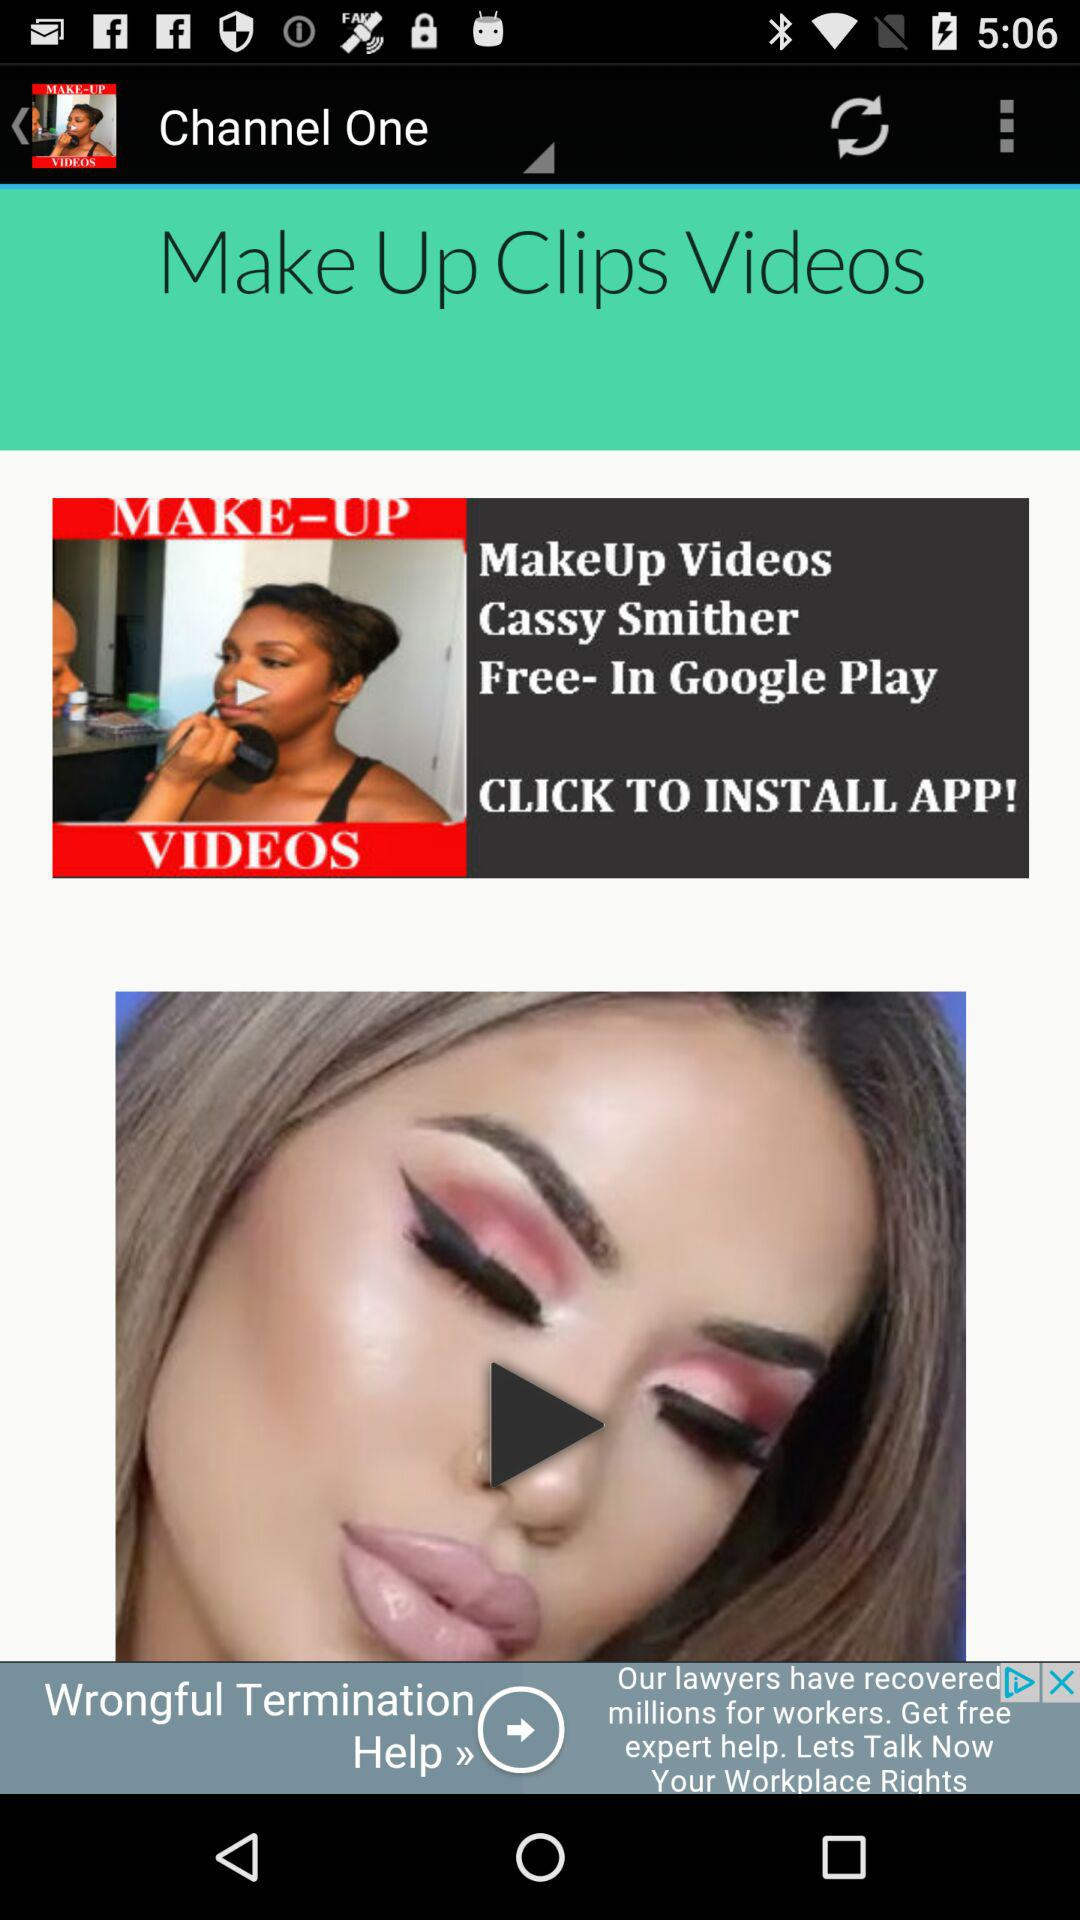What is the application name? The application name is "MakeUp Videos". 